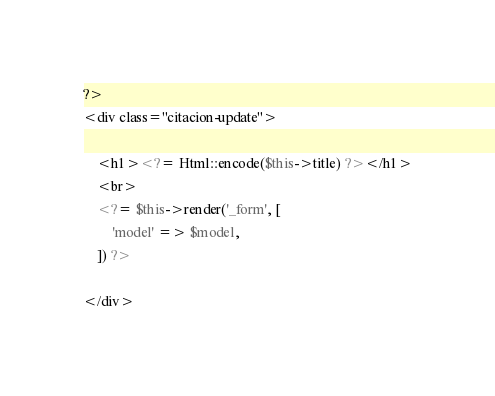Convert code to text. <code><loc_0><loc_0><loc_500><loc_500><_PHP_>?>
<div class="citacion-update">

    <h1><?= Html::encode($this->title) ?></h1>
    <br>
    <?= $this->render('_form', [
        'model' => $model,
    ]) ?>

</div>
</code> 